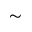Convert formula to latex. <formula><loc_0><loc_0><loc_500><loc_500>\sim</formula> 